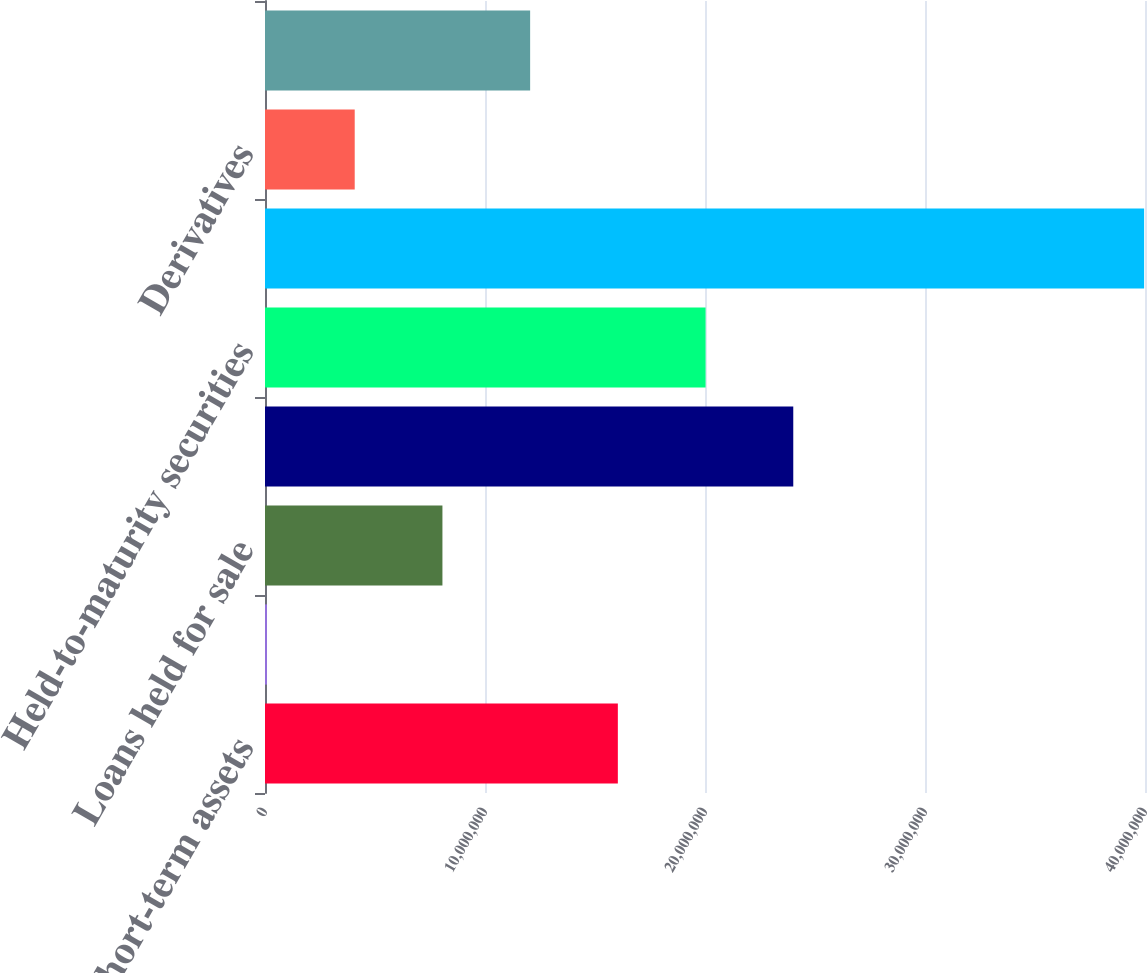Convert chart to OTSL. <chart><loc_0><loc_0><loc_500><loc_500><bar_chart><fcel>Cash and short-term assets<fcel>Trading account securities<fcel>Loans held for sale<fcel>Available-for-sale and other<fcel>Held-to-maturity securities<fcel>Net loans and direct financing<fcel>Derivatives<fcel>Subordinated notes<nl><fcel>1.60385e+07<fcel>91205<fcel>8.06483e+06<fcel>2.40121e+07<fcel>2.00253e+07<fcel>3.99594e+07<fcel>4.07802e+06<fcel>1.20516e+07<nl></chart> 